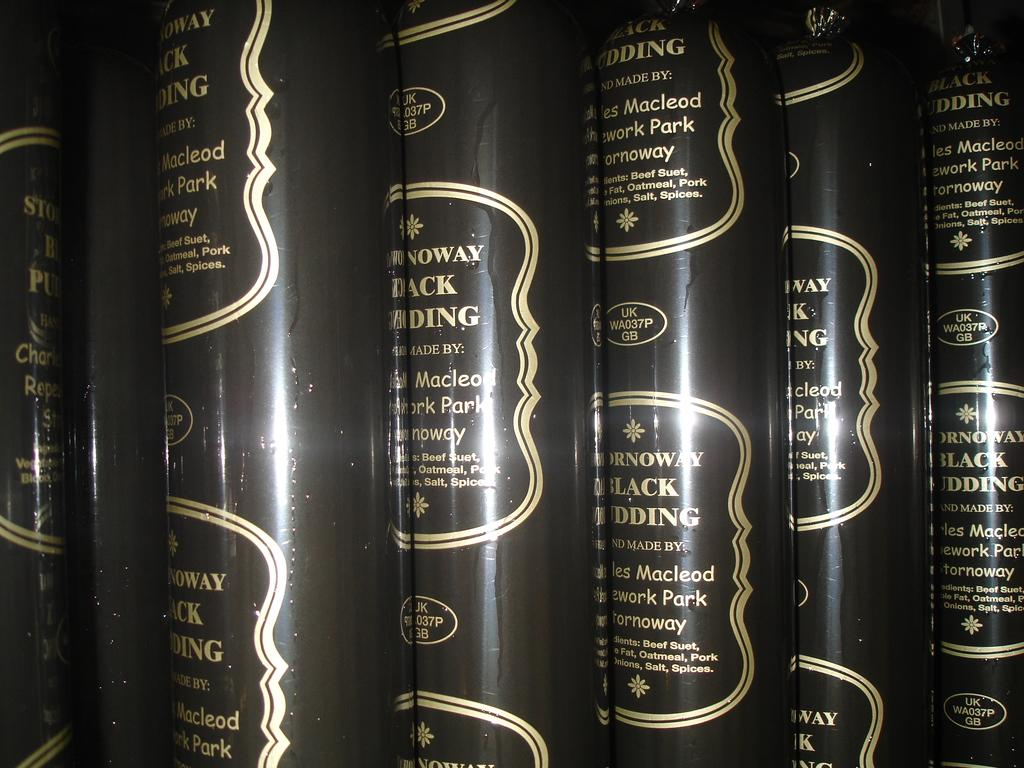Provide a one-sentence caption for the provided image. Six tubes of Stornoway Black Pudding are stacked side by side. 